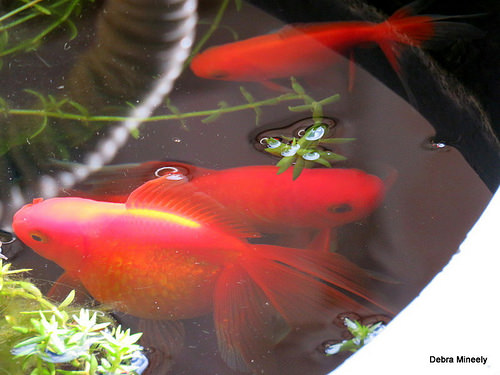<image>
Is there a fish in front of the water? No. The fish is not in front of the water. The spatial positioning shows a different relationship between these objects. 